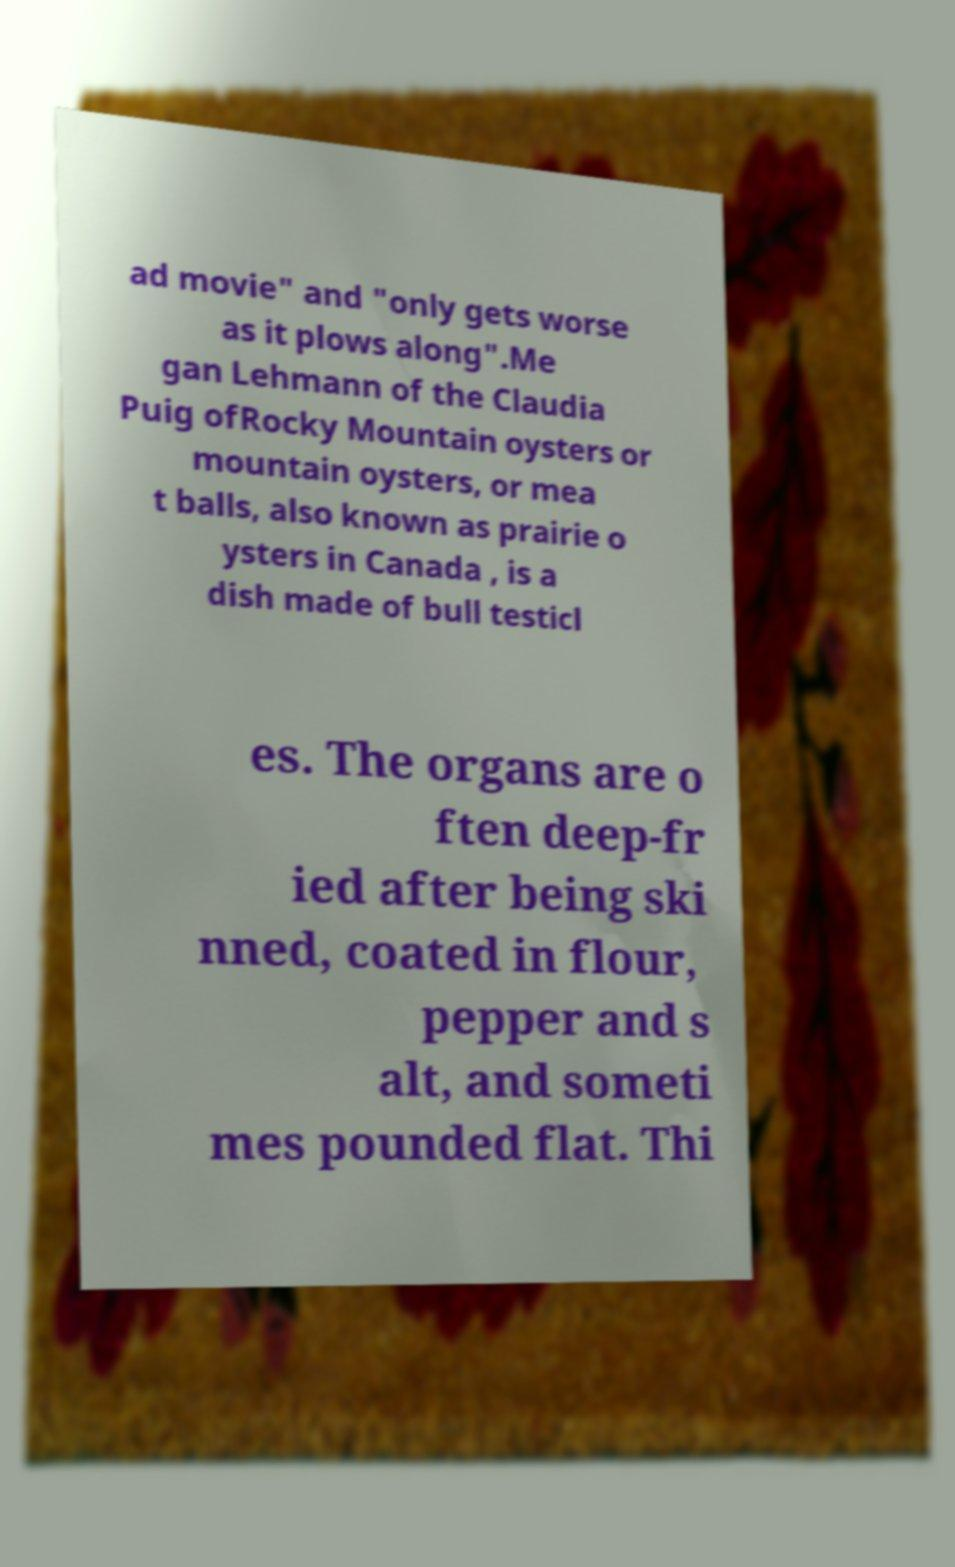For documentation purposes, I need the text within this image transcribed. Could you provide that? ad movie" and "only gets worse as it plows along".Me gan Lehmann of the Claudia Puig ofRocky Mountain oysters or mountain oysters, or mea t balls, also known as prairie o ysters in Canada , is a dish made of bull testicl es. The organs are o ften deep-fr ied after being ski nned, coated in flour, pepper and s alt, and someti mes pounded flat. Thi 